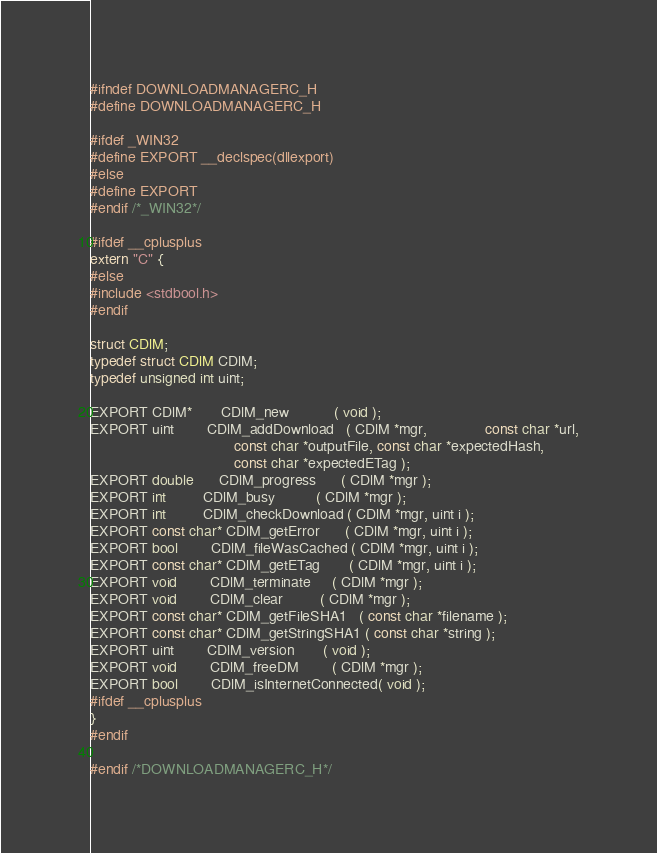<code> <loc_0><loc_0><loc_500><loc_500><_C_>#ifndef DOWNLOADMANAGERC_H
#define DOWNLOADMANAGERC_H

#ifdef _WIN32
#define EXPORT __declspec(dllexport)
#else
#define EXPORT
#endif /*_WIN32*/

#ifdef __cplusplus
extern "C" {
#else
#include <stdbool.h>
#endif

struct CDlM;
typedef struct CDlM CDlM;
typedef unsigned int uint;

EXPORT CDlM*       CDlM_new           ( void );
EXPORT uint        CDlM_addDownload   ( CDlM *mgr,              const char *url,
                                   const char *outputFile, const char *expectedHash,
                                   const char *expectedETag );
EXPORT double      CDlM_progress      ( CDlM *mgr );
EXPORT int         CDlM_busy          ( CDlM *mgr );
EXPORT int         CDlM_checkDownload ( CDlM *mgr, uint i );
EXPORT const char* CDlM_getError      ( CDlM *mgr, uint i );
EXPORT bool        CDlM_fileWasCached ( CDlM *mgr, uint i );
EXPORT const char* CDlM_getETag       ( CDlM *mgr, uint i );
EXPORT void        CDlM_terminate     ( CDlM *mgr );
EXPORT void        CDlM_clear         ( CDlM *mgr );
EXPORT const char* CDlM_getFileSHA1   ( const char *filename );
EXPORT const char* CDlM_getStringSHA1 ( const char *string );
EXPORT uint        CDlM_version       ( void );
EXPORT void        CDlM_freeDM        ( CDlM *mgr );
EXPORT bool        CDlM_isInternetConnected( void );
#ifdef __cplusplus
}
#endif

#endif /*DOWNLOADMANAGERC_H*/
</code> 